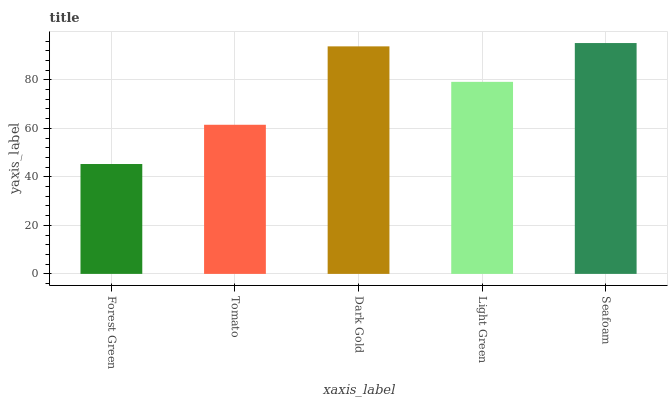Is Forest Green the minimum?
Answer yes or no. Yes. Is Seafoam the maximum?
Answer yes or no. Yes. Is Tomato the minimum?
Answer yes or no. No. Is Tomato the maximum?
Answer yes or no. No. Is Tomato greater than Forest Green?
Answer yes or no. Yes. Is Forest Green less than Tomato?
Answer yes or no. Yes. Is Forest Green greater than Tomato?
Answer yes or no. No. Is Tomato less than Forest Green?
Answer yes or no. No. Is Light Green the high median?
Answer yes or no. Yes. Is Light Green the low median?
Answer yes or no. Yes. Is Tomato the high median?
Answer yes or no. No. Is Tomato the low median?
Answer yes or no. No. 